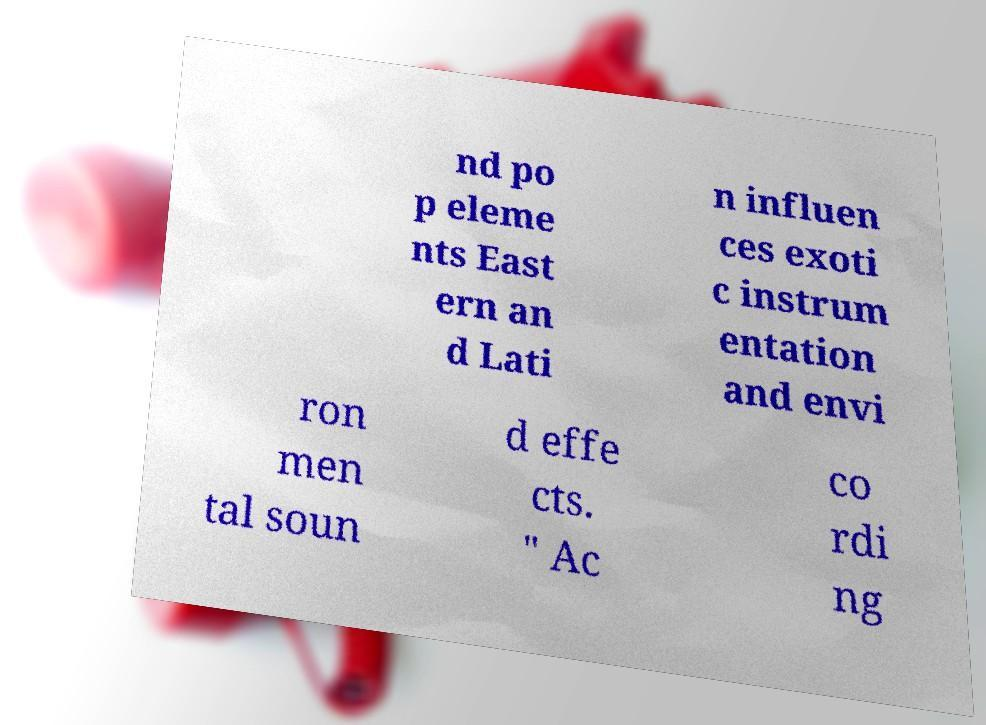Could you assist in decoding the text presented in this image and type it out clearly? nd po p eleme nts East ern an d Lati n influen ces exoti c instrum entation and envi ron men tal soun d effe cts. " Ac co rdi ng 